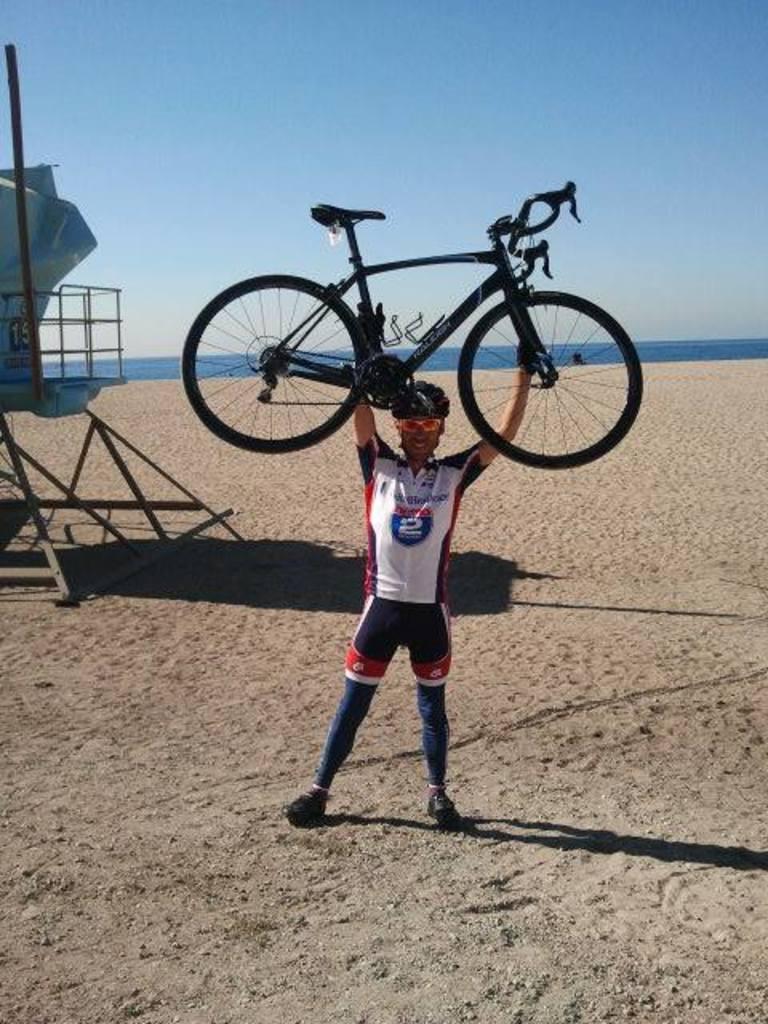What's represented on this man's jersey?
Provide a succinct answer. 2. 